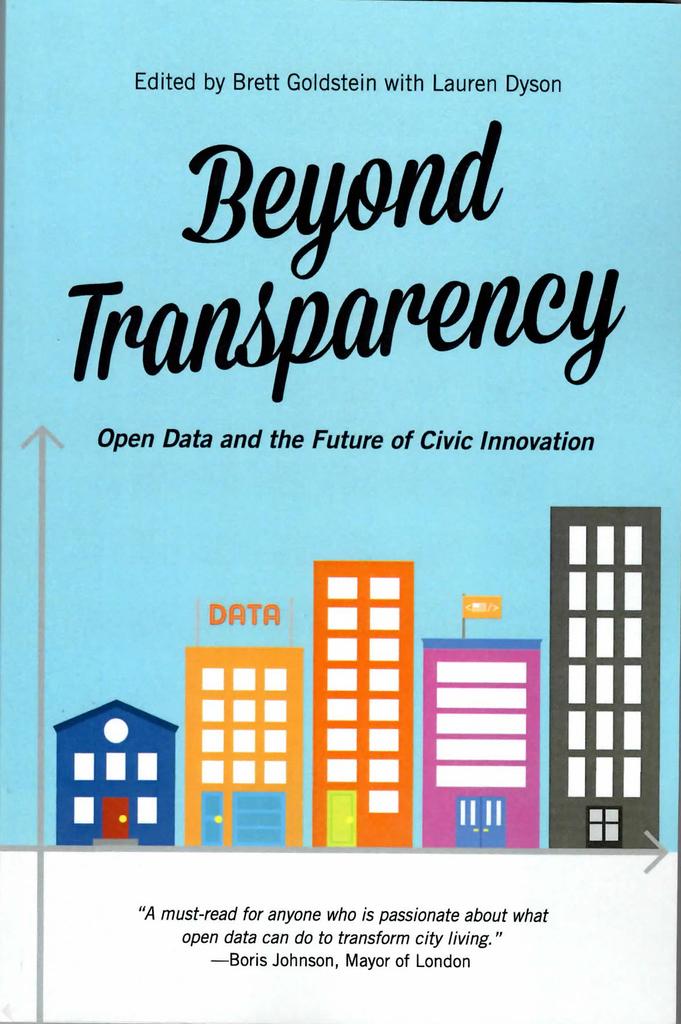What is the title of the work? beyond what?
Offer a very short reply. Transparency. Who edited this book?
Keep it short and to the point. Brett goldstein and lauren dyson. 